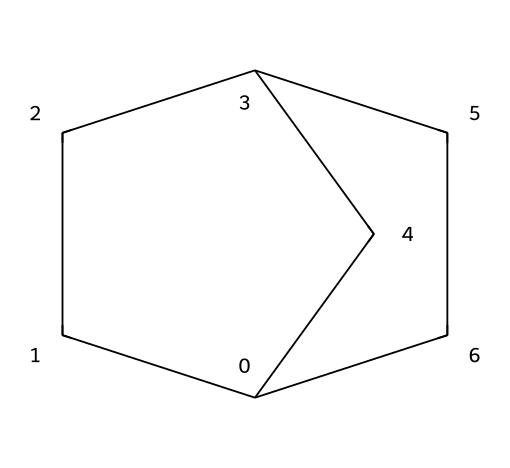What is the molecular formula of bicyclo[2.2.1]heptane? By analyzing the structure given by the SMILES notation, we can identify there are seven carbon atoms (C) and twelve hydrogen atoms (H). Thus, the molecular formula can be formulated as C7H12.
Answer: C7H12 How many rings are present in bicyclo[2.2.1]heptane? The term "bicyclo" indicates that there are two distinct ring structures in the molecule. This is supported by the chemical's structure, which fits the definition of a bicyclic compound.
Answer: 2 What type of chemical structure does bicyclo[2.2.1]heptane represent? The structure shows a closed ring with carbon atoms. Bicyclo[2.2.1]heptane belongs to the class of cycloalkanes, specifically a bicyclic cycloalkane.
Answer: bicyclic cycloalkane Is bicyclo[2.2.1]heptane saturated or unsaturated? The presence of single bonds only between the carbon atoms and the saturation of hydrogen atoms indicates that bicyclo[2.2.1]heptane is a saturated hydrocarbon.
Answer: saturated What is the total number of carbon atoms in bicyclo[2.2.1]heptane? The count from the structure reveals there are a total of seven carbon atoms, as indicated by the notation used in the SMILES representation and by counting the individual carbon atoms within the structure.
Answer: 7 Which type of bonding is primarily present in bicyclo[2.2.1]heptane? Upon examining the bonds between the carbon atoms, it is clear that all bonds are single bonds characteristic of alkane structures, indicating a predominance of sigma bonding.
Answer: sigma bonds What is the total number of hydrogen atoms in bicyclo[2.2.1]heptane? Based on the molecular formula derived from the structure, which has seven carbon atoms, the count of hydrogen atoms is determined to be twelve, following the typical saturation rule for cycloalkanes.
Answer: 12 